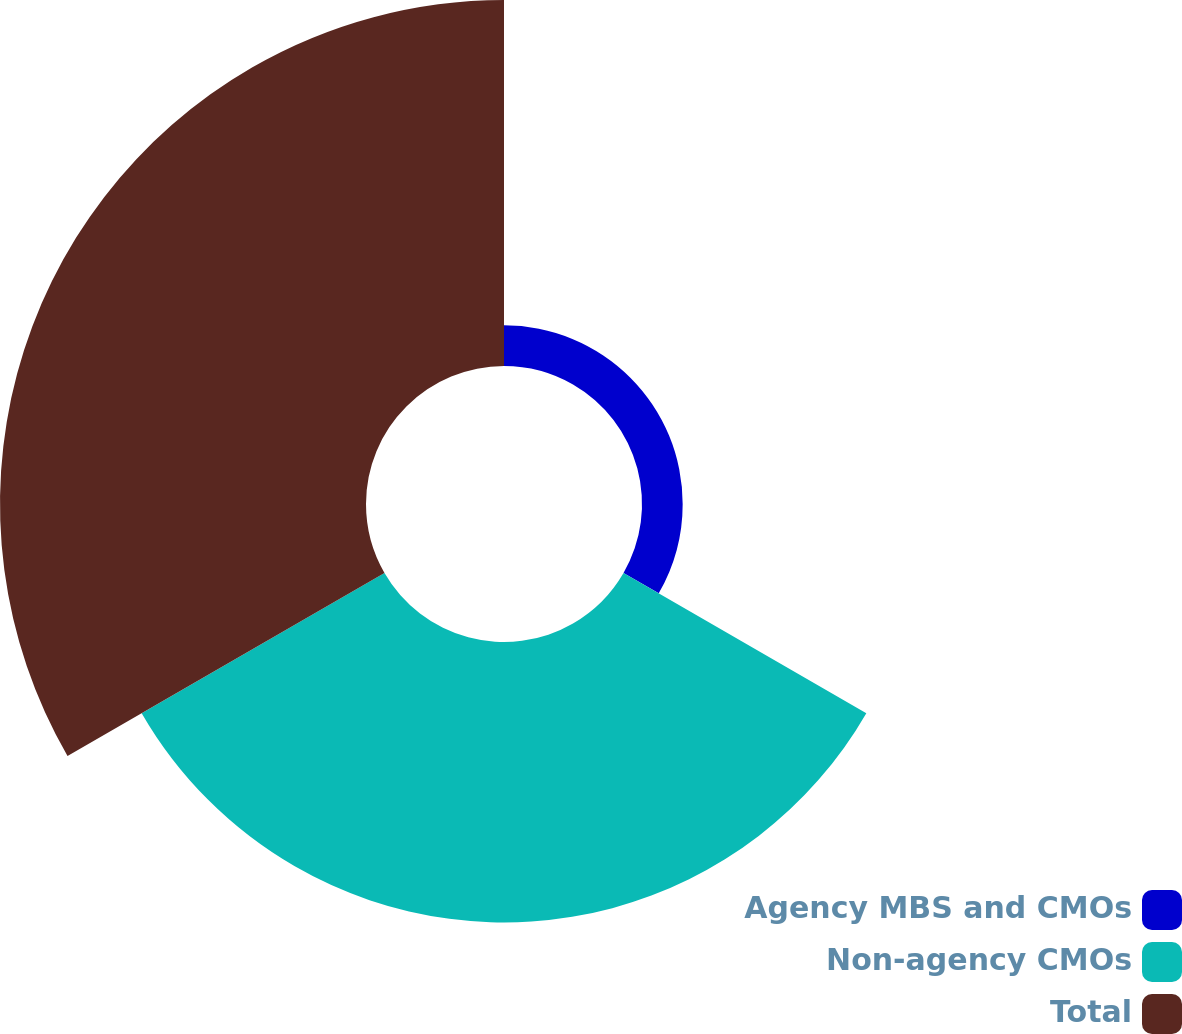Convert chart. <chart><loc_0><loc_0><loc_500><loc_500><pie_chart><fcel>Agency MBS and CMOs<fcel>Non-agency CMOs<fcel>Total<nl><fcel>5.92%<fcel>40.81%<fcel>53.27%<nl></chart> 